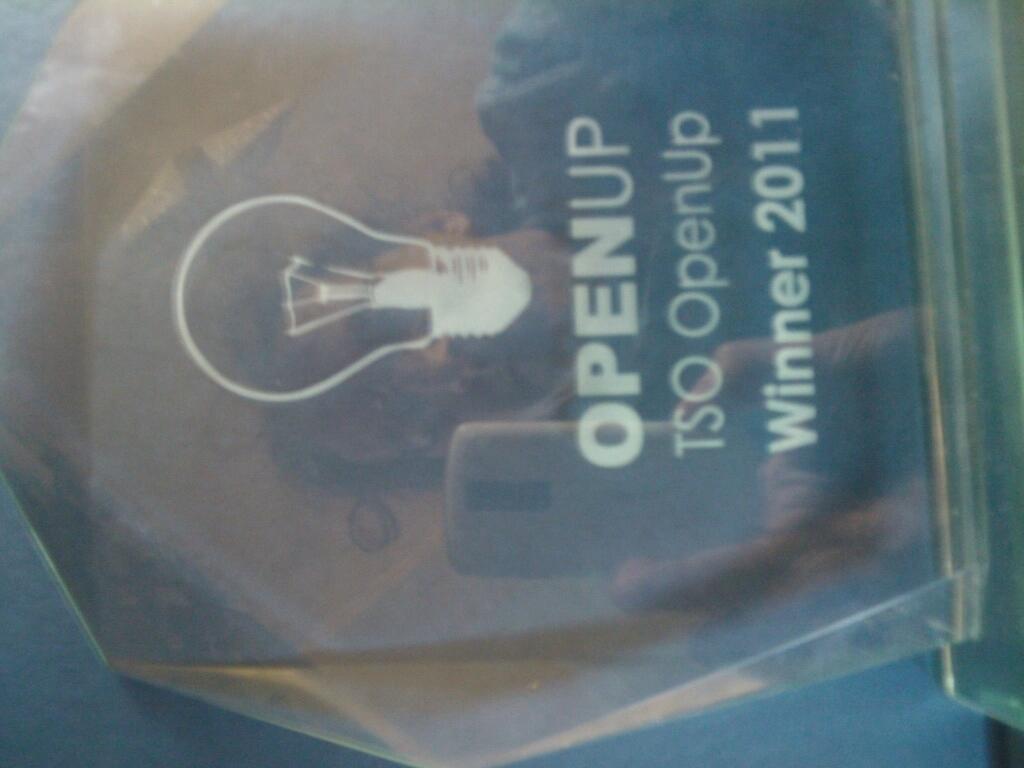What is the year shown?
Make the answer very short. 2011. 